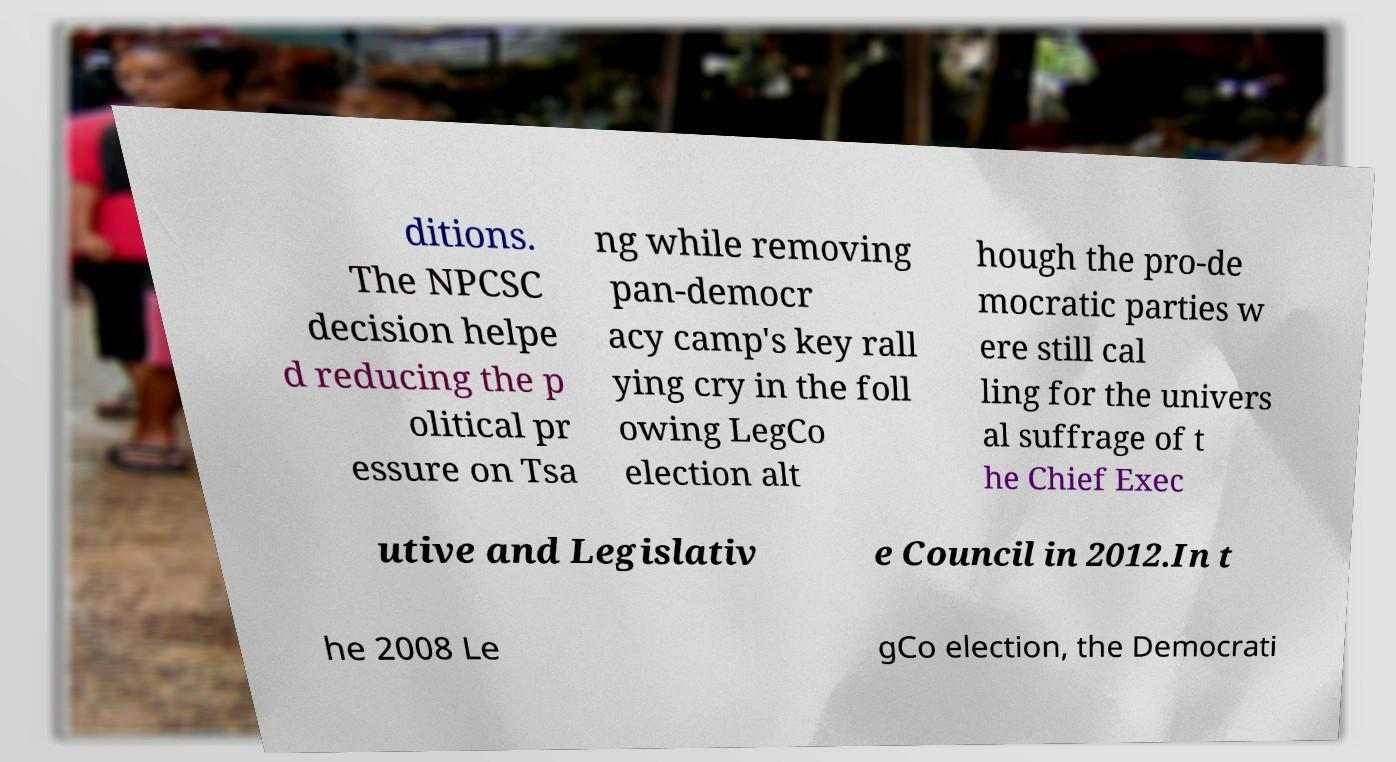For documentation purposes, I need the text within this image transcribed. Could you provide that? ditions. The NPCSC decision helpe d reducing the p olitical pr essure on Tsa ng while removing pan-democr acy camp's key rall ying cry in the foll owing LegCo election alt hough the pro-de mocratic parties w ere still cal ling for the univers al suffrage of t he Chief Exec utive and Legislativ e Council in 2012.In t he 2008 Le gCo election, the Democrati 